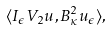Convert formula to latex. <formula><loc_0><loc_0><loc_500><loc_500>\langle I _ { \epsilon } V _ { 2 } u , B _ { \kappa } ^ { 2 } u _ { \epsilon } \rangle ,</formula> 